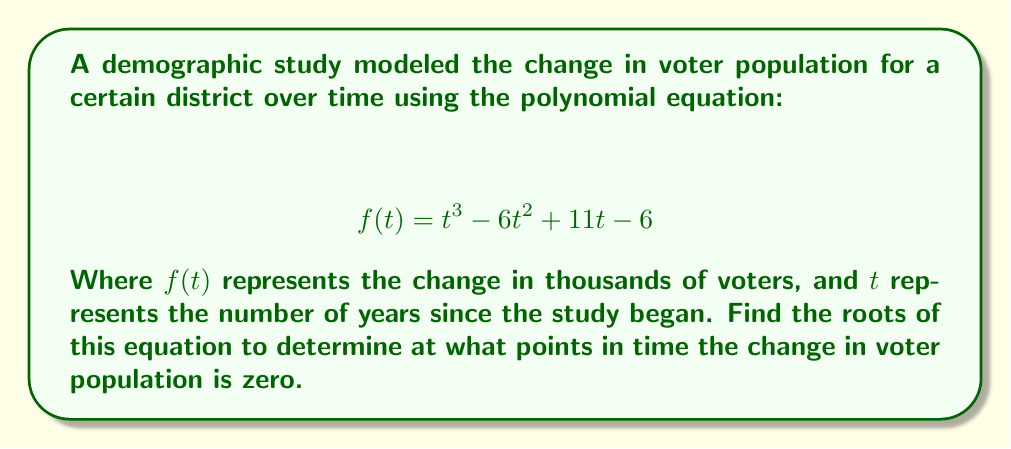Can you answer this question? To find the roots of this polynomial equation, we need to factor it. Let's approach this step-by-step:

1) First, we can check if there are any rational roots using the rational root theorem. The possible rational roots are the factors of the constant term: ±1, ±2, ±3, ±6.

2) Testing these values, we find that $f(1) = 0$. So $(t-1)$ is a factor.

3) We can use polynomial long division to divide $f(t)$ by $(t-1)$:

   $$ t^3 - 6t^2 + 11t - 6 = (t-1)(t^2 - 5t + 6) $$

4) Now we need to factor the quadratic term $t^2 - 5t + 6$. We can do this by finding two numbers that multiply to give 6 and add to give -5. These numbers are -2 and -3.

5) So our final factorization is:

   $$ f(t) = (t-1)(t-2)(t-3) $$

6) The roots of the equation are the values of $t$ that make each factor equal to zero. So the roots are $t = 1$, $t = 2$, and $t = 3$.

These roots represent the points in time (in years since the study began) when the change in voter population is zero.
Answer: The roots of the equation are $t = 1$, $t = 2$, and $t = 3$. 